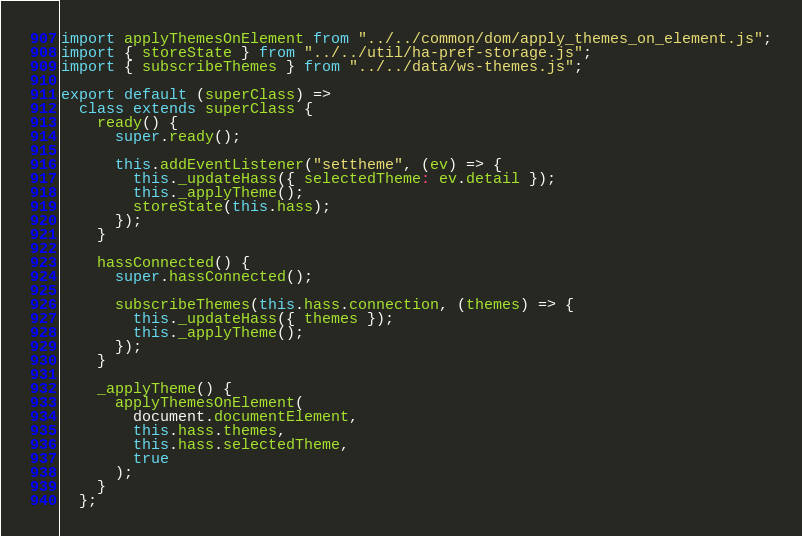<code> <loc_0><loc_0><loc_500><loc_500><_JavaScript_>import applyThemesOnElement from "../../common/dom/apply_themes_on_element.js";
import { storeState } from "../../util/ha-pref-storage.js";
import { subscribeThemes } from "../../data/ws-themes.js";

export default (superClass) =>
  class extends superClass {
    ready() {
      super.ready();

      this.addEventListener("settheme", (ev) => {
        this._updateHass({ selectedTheme: ev.detail });
        this._applyTheme();
        storeState(this.hass);
      });
    }

    hassConnected() {
      super.hassConnected();

      subscribeThemes(this.hass.connection, (themes) => {
        this._updateHass({ themes });
        this._applyTheme();
      });
    }

    _applyTheme() {
      applyThemesOnElement(
        document.documentElement,
        this.hass.themes,
        this.hass.selectedTheme,
        true
      );
    }
  };
</code> 